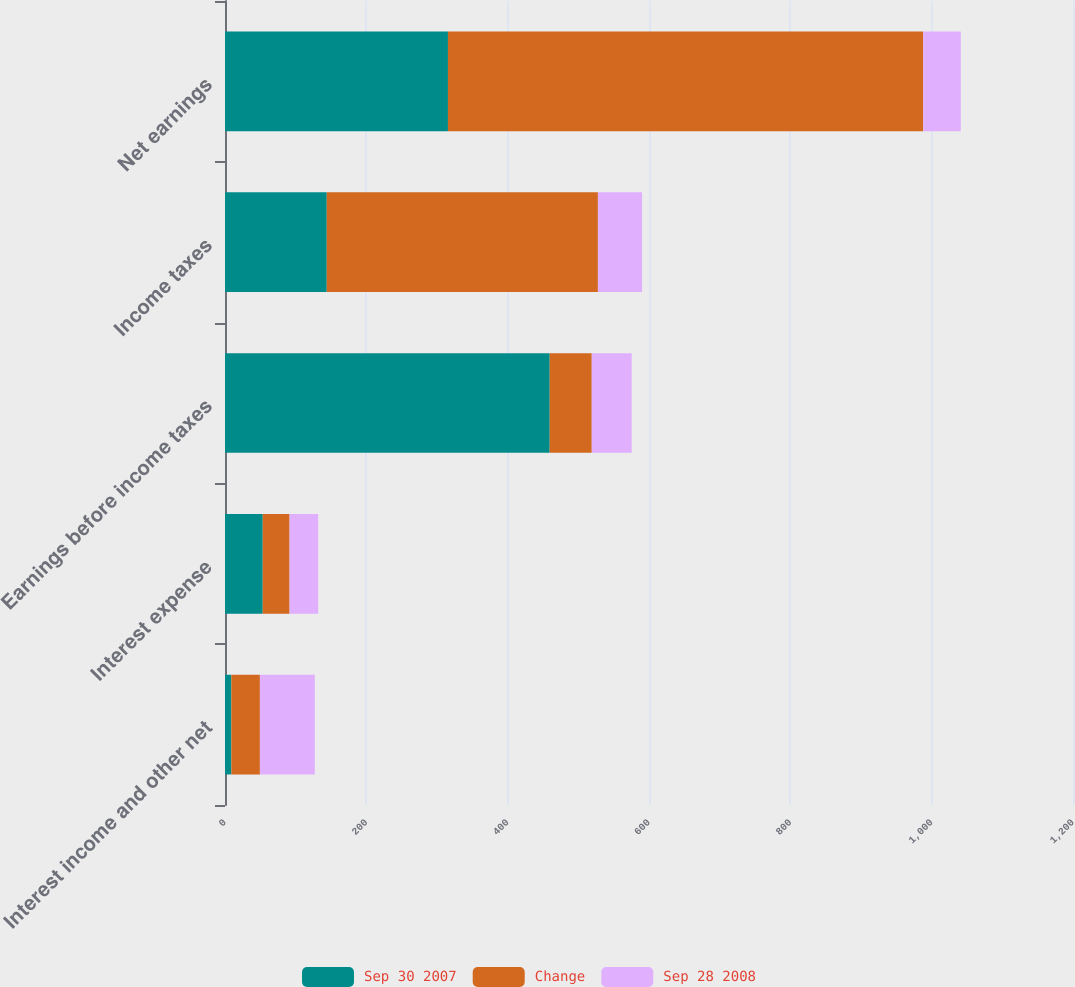Convert chart. <chart><loc_0><loc_0><loc_500><loc_500><stacked_bar_chart><ecel><fcel>Interest income and other net<fcel>Interest expense<fcel>Earnings before income taxes<fcel>Income taxes<fcel>Net earnings<nl><fcel>Sep 30 2007<fcel>9<fcel>53.4<fcel>459.5<fcel>144<fcel>315.5<nl><fcel>Change<fcel>40.4<fcel>38<fcel>59.5<fcel>383.7<fcel>672.6<nl><fcel>Sep 28 2008<fcel>77.7<fcel>40.5<fcel>56.5<fcel>62.5<fcel>53.1<nl></chart> 